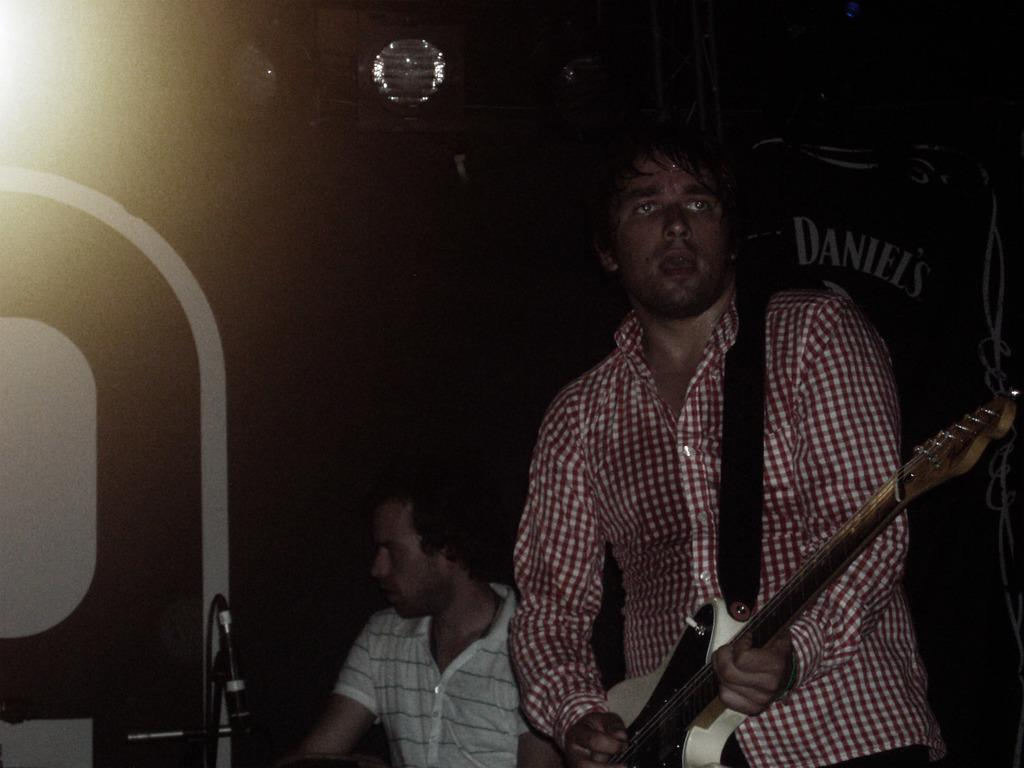How many people are in the image? There are two persons in the image. What is one of the persons doing in the image? One of the persons is playing a guitar. What type of pleasure can be seen on the toes of the person playing the guitar in the image? There is no indication of the person's toes in the image, and therefore no such pleasure can be observed. 